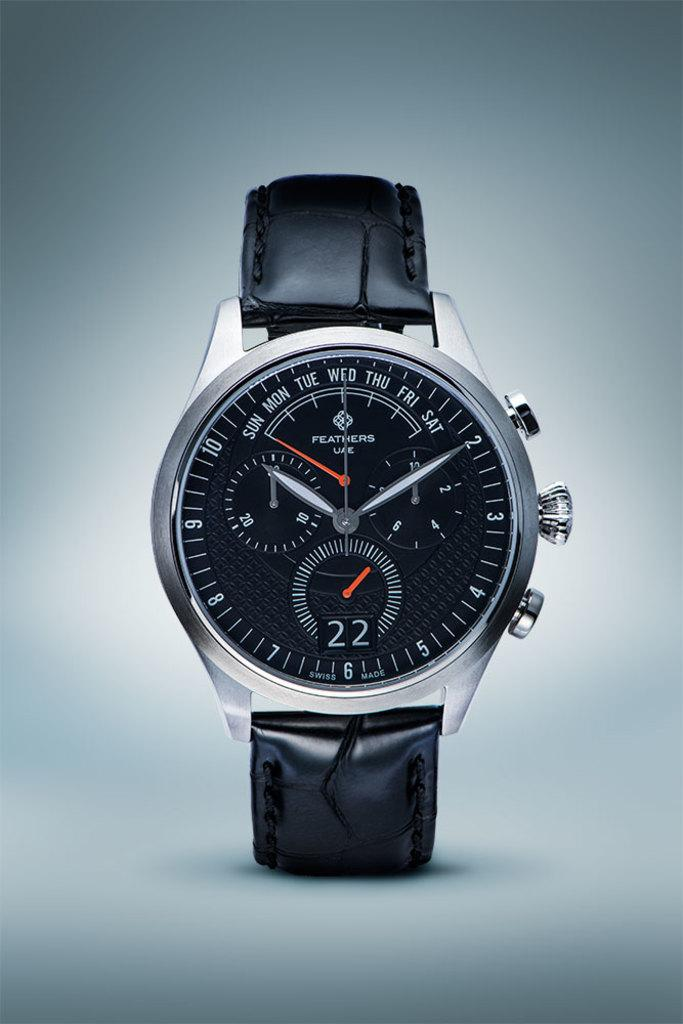<image>
Describe the image concisely. Black, silver, white, and red watch that tells time and days of the week 